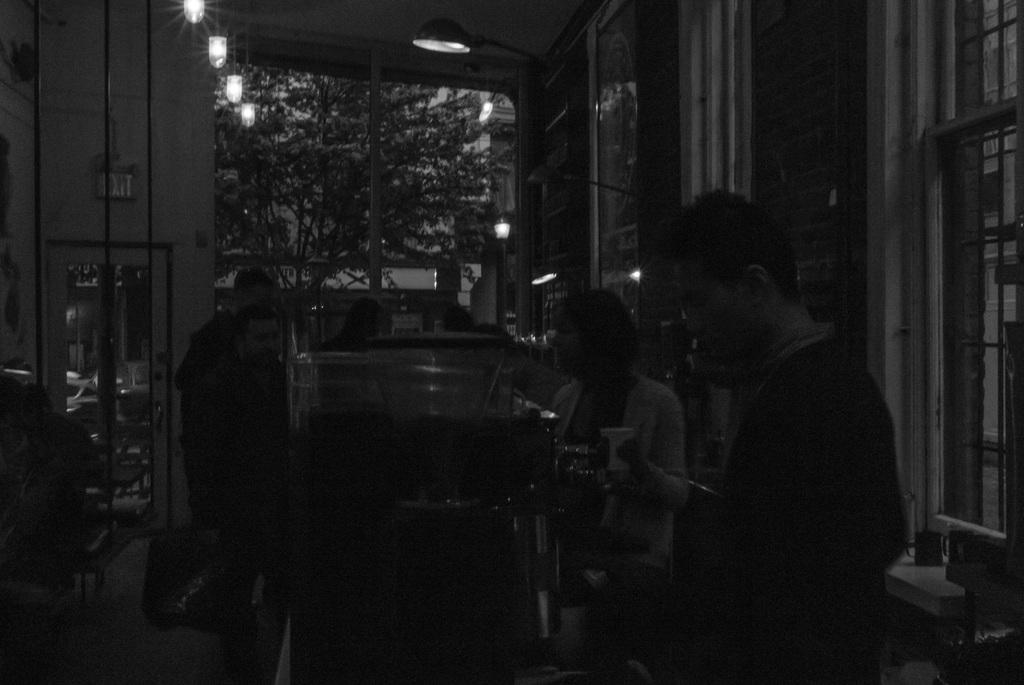What is the color scheme of the image? The image is black and white. What type of furniture can be seen in the image? There are tables and chairs in the image. Are there any people present in the image? Yes, there are persons in the image. What type of lighting is visible in the image? There are lights in the image. What architectural feature is present in the image? There are windows in the image. What type of natural element is visible in the image? There are trees in the image. What type of structure is present in the image? There is a building in the image. What type of pancake is being served at the table in the image? There is no pancake present in the image; it is a black and white image featuring tables, chairs, persons, lights, windows, trees, and a building. 